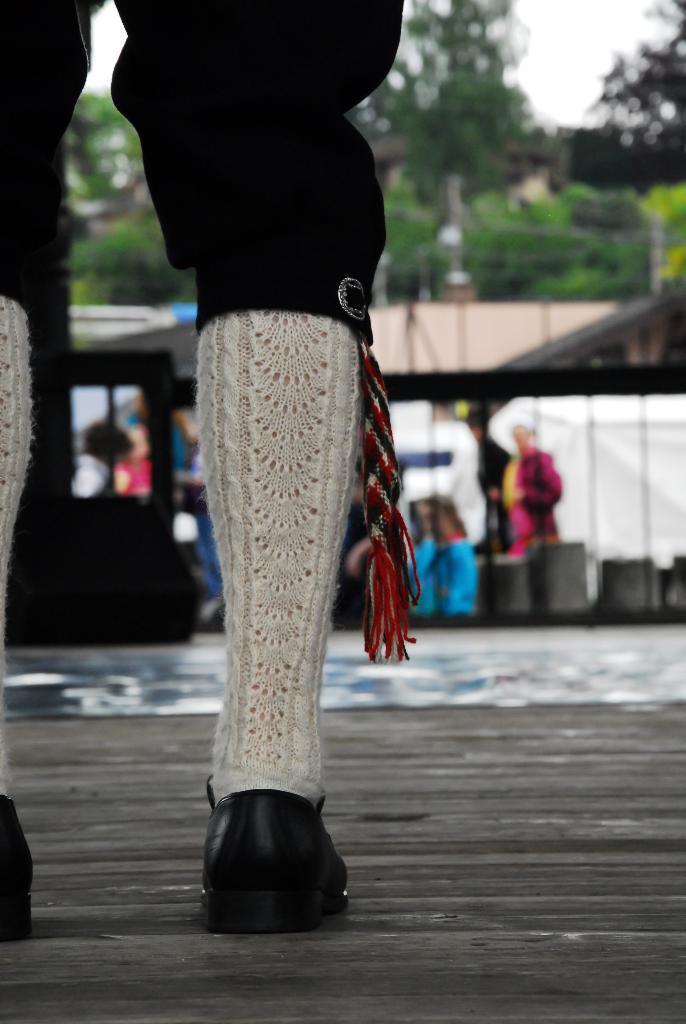Please provide a concise description of this image. In front of the picture, we see the legs of the person wearing black pant, black shoes and white socks. In the background, we see people standing under the tents. Beside that, we see a vehicle in white color and a building in white color. There are many trees in the background. 